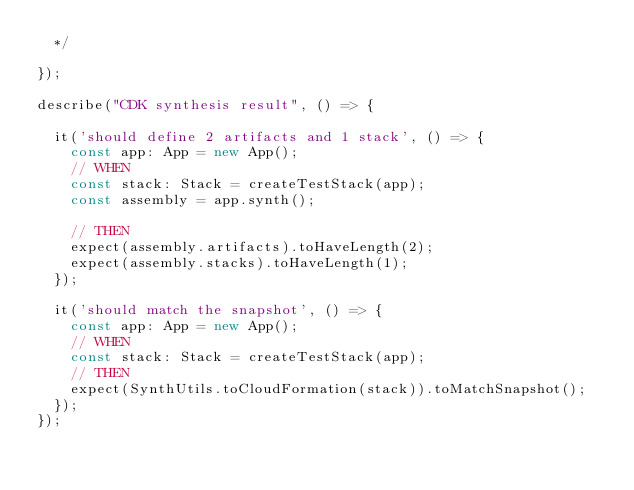Convert code to text. <code><loc_0><loc_0><loc_500><loc_500><_TypeScript_>  */

});

describe("CDK synthesis result", () => {

  it('should define 2 artifacts and 1 stack', () => {
    const app: App = new App();
    // WHEN
    const stack: Stack = createTestStack(app);
    const assembly = app.synth();

    // THEN
    expect(assembly.artifacts).toHaveLength(2);
    expect(assembly.stacks).toHaveLength(1);
  });

  it('should match the snapshot', () => {
    const app: App = new App();
    // WHEN
    const stack: Stack = createTestStack(app);
    // THEN
    expect(SynthUtils.toCloudFormation(stack)).toMatchSnapshot();
  });
});
</code> 